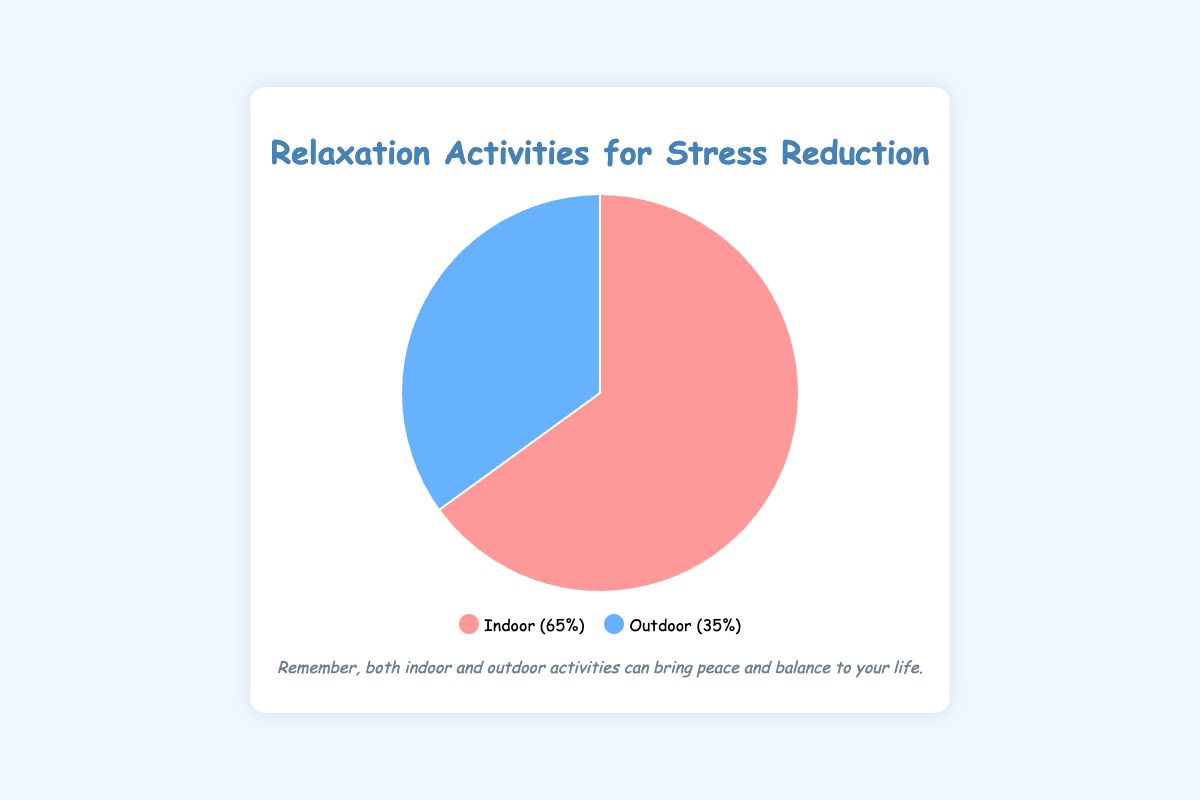What percentage of relaxation activities are performed indoors? Look at the chart legend that marks indoor activities and shows a percentage. It states "Indoor (65%)".
Answer: 65% Which type of activity has a higher percentage in the chart? Compare the percentages mentioned in the legend for both activities. Indoor activities have 65%, while Outdoor activities have 35%, so Indoor has a higher percentage.
Answer: Indoor What is the difference in percentage points between indoor and outdoor activities? Subtract the percentage of outdoor activities from the percentage of indoor activities: 65% - 35% = 30%.
Answer: 30% What portions of the pie chart are colored red and blue, respectively? The legend indicates that the red portion represents indoor activities and the blue portion represents outdoor activities. Observe the chart to match these colors.
Answer: Red: Indoor, Blue: Outdoor If you were to combine Meditation and Walking in Nature under one new category, how would the pie chart change? Combine indoor and outdoor percentages: 65% + 35% = 100% for the new category. The new pie chart would have a single section representing 100% combined activities.
Answer: 100% combined Based on the chart, give two examples of outdoor activities. Refer to the tooltip information under the outdoor activities segment. It lists examples like "Walking in Nature", "Gardening", "Running", "Biking", "Beach Relaxation".
Answer: "Walking in Nature", "Gardening" Given the data, compute the ratio of indoor activities to outdoor activities. Divide the percentage of indoor activities by the percentage of outdoor activities: 65% / 35%. Simplify the ratio: 65 ÷ 5 = 13, 35 ÷ 5 = 7.
Answer: 13 to 7 How many more percent of relaxation activities are done indoors compared to outdoors? Subtract the outdoor percentage from the indoor percentage: 65% - 35% = 30%.
Answer: 30% Which type of activity, indoor or outdoor, could be represented by the larger segment of the pie chart? Observe which segment visually appears larger and confirm with the percentage. The larger segment, which is red, represents the 65% of indoor activities.
Answer: Indoor 